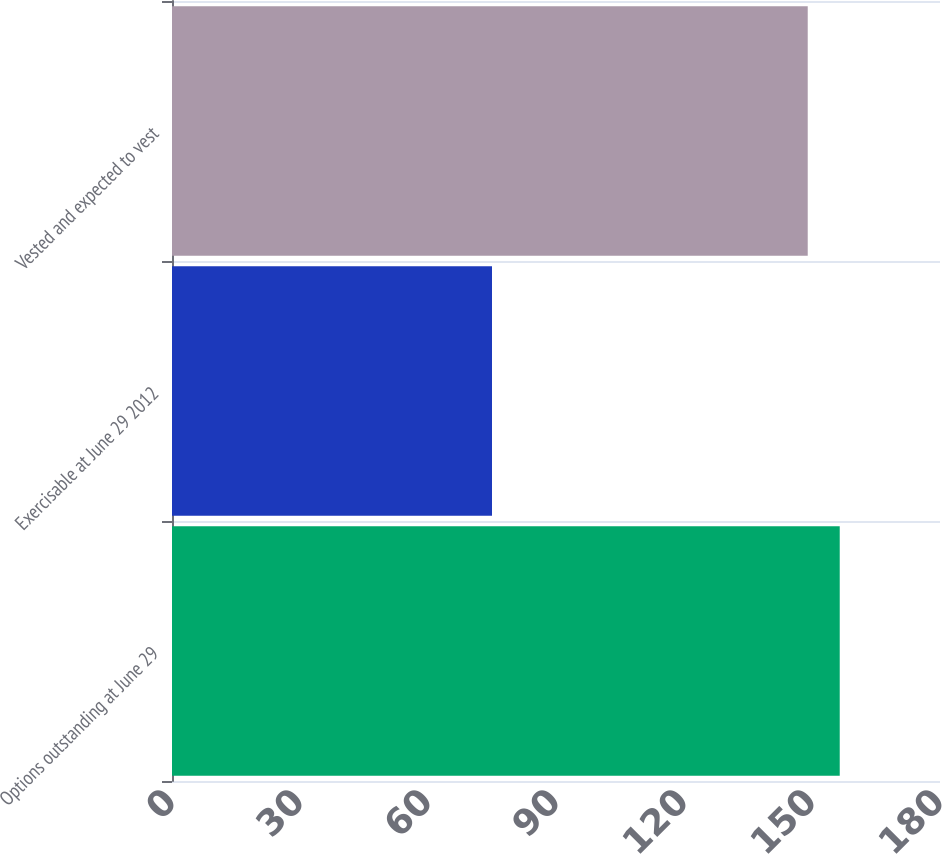<chart> <loc_0><loc_0><loc_500><loc_500><bar_chart><fcel>Options outstanding at June 29<fcel>Exercisable at June 29 2012<fcel>Vested and expected to vest<nl><fcel>156.5<fcel>75<fcel>149<nl></chart> 